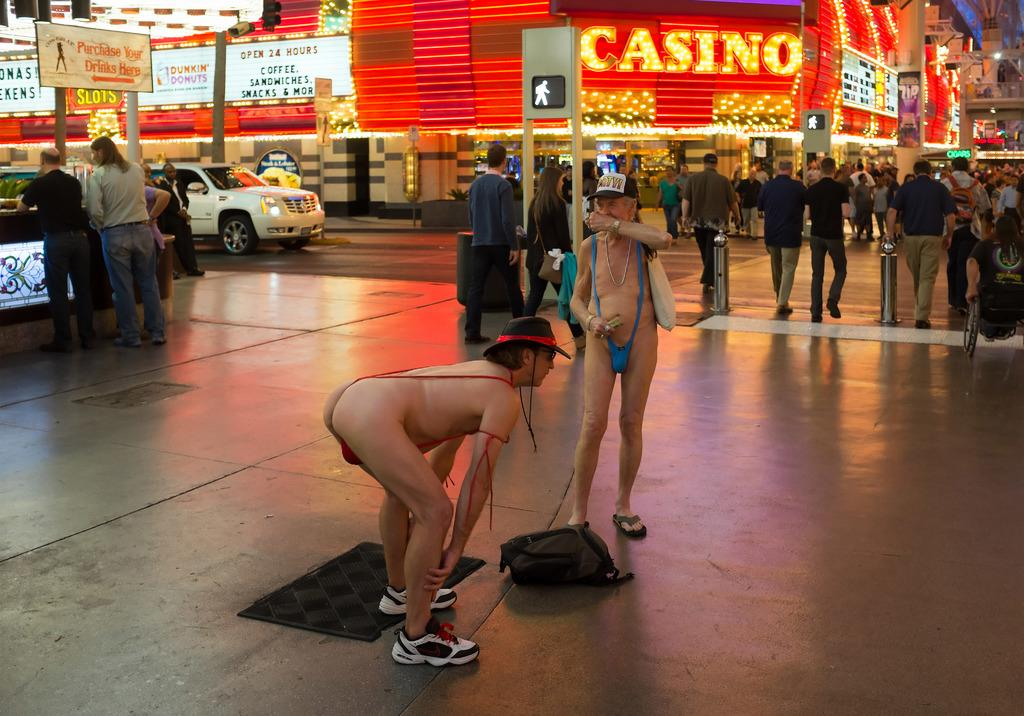Who or what can be seen in the image? There are people in the image. What are the boards in the image used for? Something is written on the boards, which suggests they might be used for displaying information or advertisements. What type of structures are visible in the image? There are buildings in the image. What mode of transportation is present in the image? There is a vehicle in the image. What type of establishment is depicted in the image? There is a store in the image. What can be seen illuminating the scene in the image? There are lights in the image. What else can be observed in the image besides the people and the boards? There are objects in the image. What are some people doing in the image? Some people are walking in the image. Can you recite the verse written on the boards in the image? There is no verse present on the boards in the image; only written information or advertisements can be seen. Are there any chickens visible in the image? There are no chickens present in the image. Is there any quicksand in the image? There is no quicksand present in the image. 